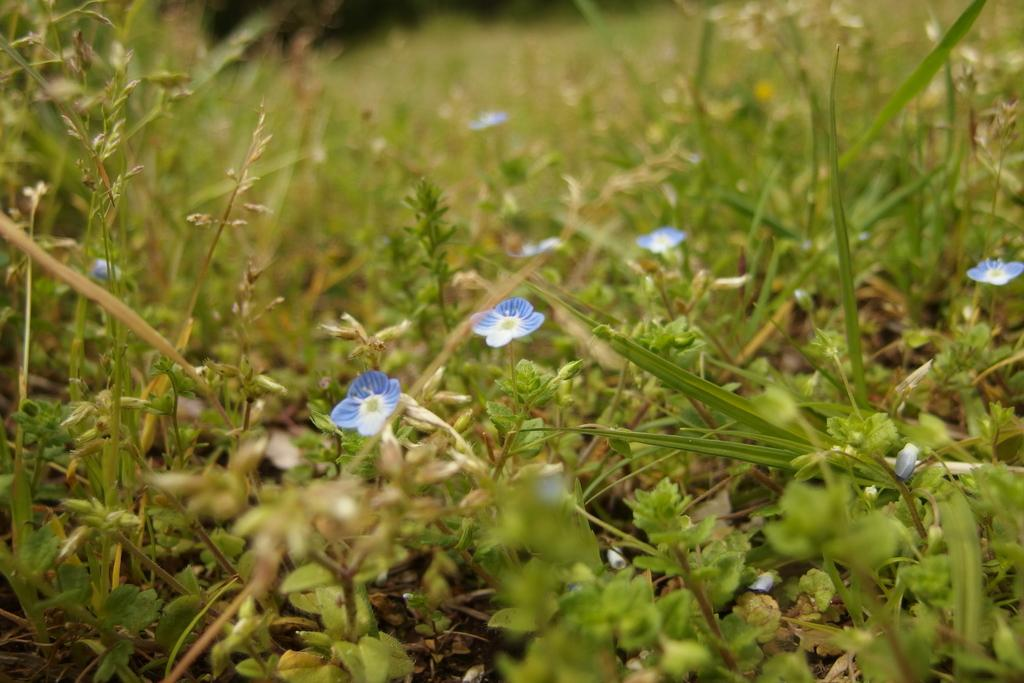What types of living organisms can be seen in the image? There are many plants in the image. Can you describe any specific features of the plants? Yes, there are purple flowers in the image. What type of connection can be seen between the plants in the image? There is no connection between the plants mentioned in the image. What is located at the back of the image? The provided facts do not mention anything about the back of the image. 